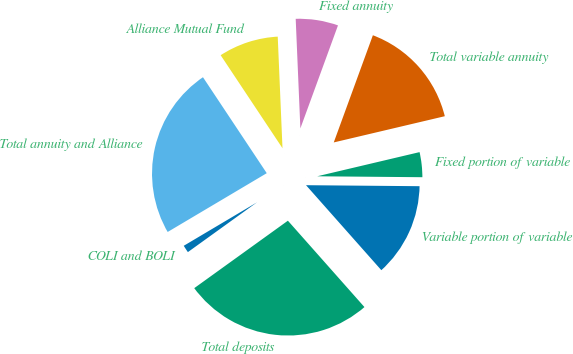Convert chart to OTSL. <chart><loc_0><loc_0><loc_500><loc_500><pie_chart><fcel>Variable portion of variable<fcel>Fixed portion of variable<fcel>Total variable annuity<fcel>Fixed annuity<fcel>Alliance Mutual Fund<fcel>Total annuity and Alliance<fcel>COLI and BOLI<fcel>Total deposits<nl><fcel>13.32%<fcel>3.83%<fcel>15.74%<fcel>6.25%<fcel>8.66%<fcel>24.19%<fcel>1.41%<fcel>26.61%<nl></chart> 